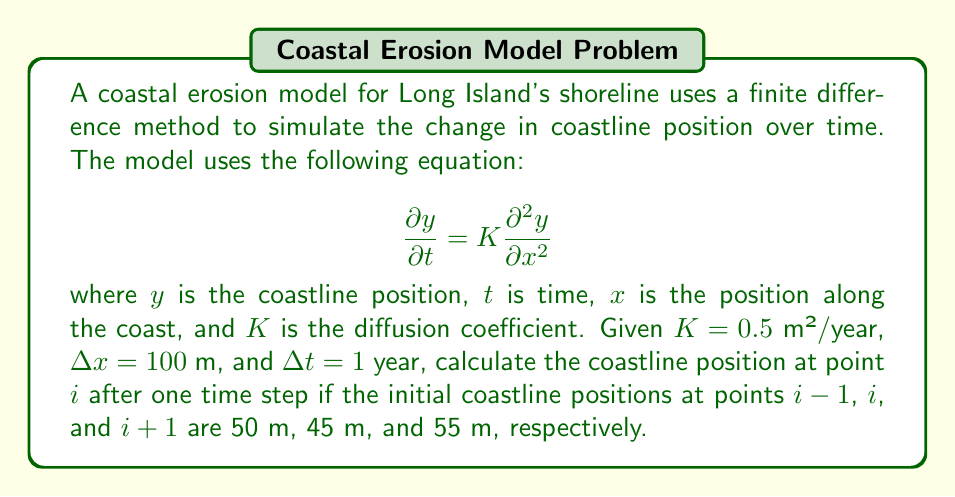What is the answer to this math problem? To solve this problem, we'll use the finite difference method to discretize the partial differential equation and solve for the new coastline position.

Step 1: Discretize the equation using the forward difference for time and central difference for space:

$$\frac{y_i^{n+1} - y_i^n}{\Delta t} = K \frac{y_{i+1}^n - 2y_i^n + y_{i-1}^n}{(\Delta x)^2}$$

Step 2: Rearrange the equation to solve for $y_i^{n+1}$:

$$y_i^{n+1} = y_i^n + K\frac{\Delta t}{(\Delta x)^2}(y_{i+1}^n - 2y_i^n + y_{i-1}^n)$$

Step 3: Substitute the given values:
$K = 0.5$ m²/year
$\Delta x = 100$ m
$\Delta t = 1$ year
$y_{i-1}^n = 50$ m
$y_i^n = 45$ m
$y_{i+1}^n = 55$ m

Step 4: Calculate the new coastline position:

$$\begin{aligned}
y_i^{n+1} &= 45 + 0.5 \cdot \frac{1}{(100)^2}(55 - 2(45) + 50) \\
&= 45 + 0.5 \cdot 0.0001 \cdot 15 \\
&= 45 + 0.00075 \\
&= 45.00075 \text{ m}
\end{aligned}$$

Therefore, the new coastline position at point $i$ after one time step is 45.00075 m.
Answer: 45.00075 m 